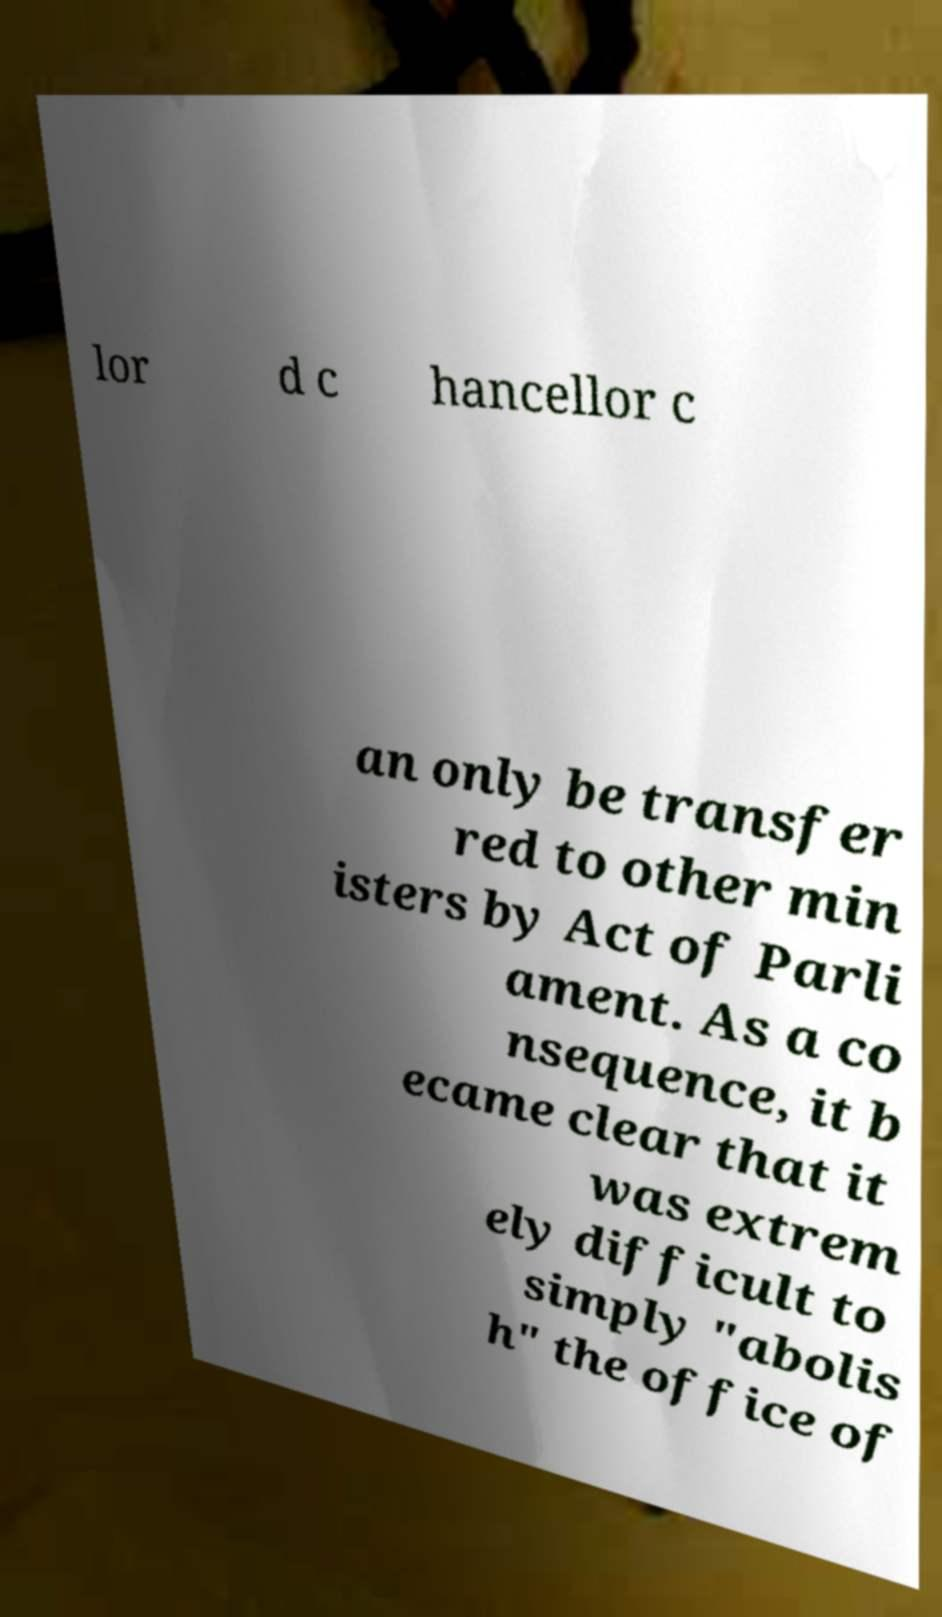I need the written content from this picture converted into text. Can you do that? lor d c hancellor c an only be transfer red to other min isters by Act of Parli ament. As a co nsequence, it b ecame clear that it was extrem ely difficult to simply "abolis h" the office of 